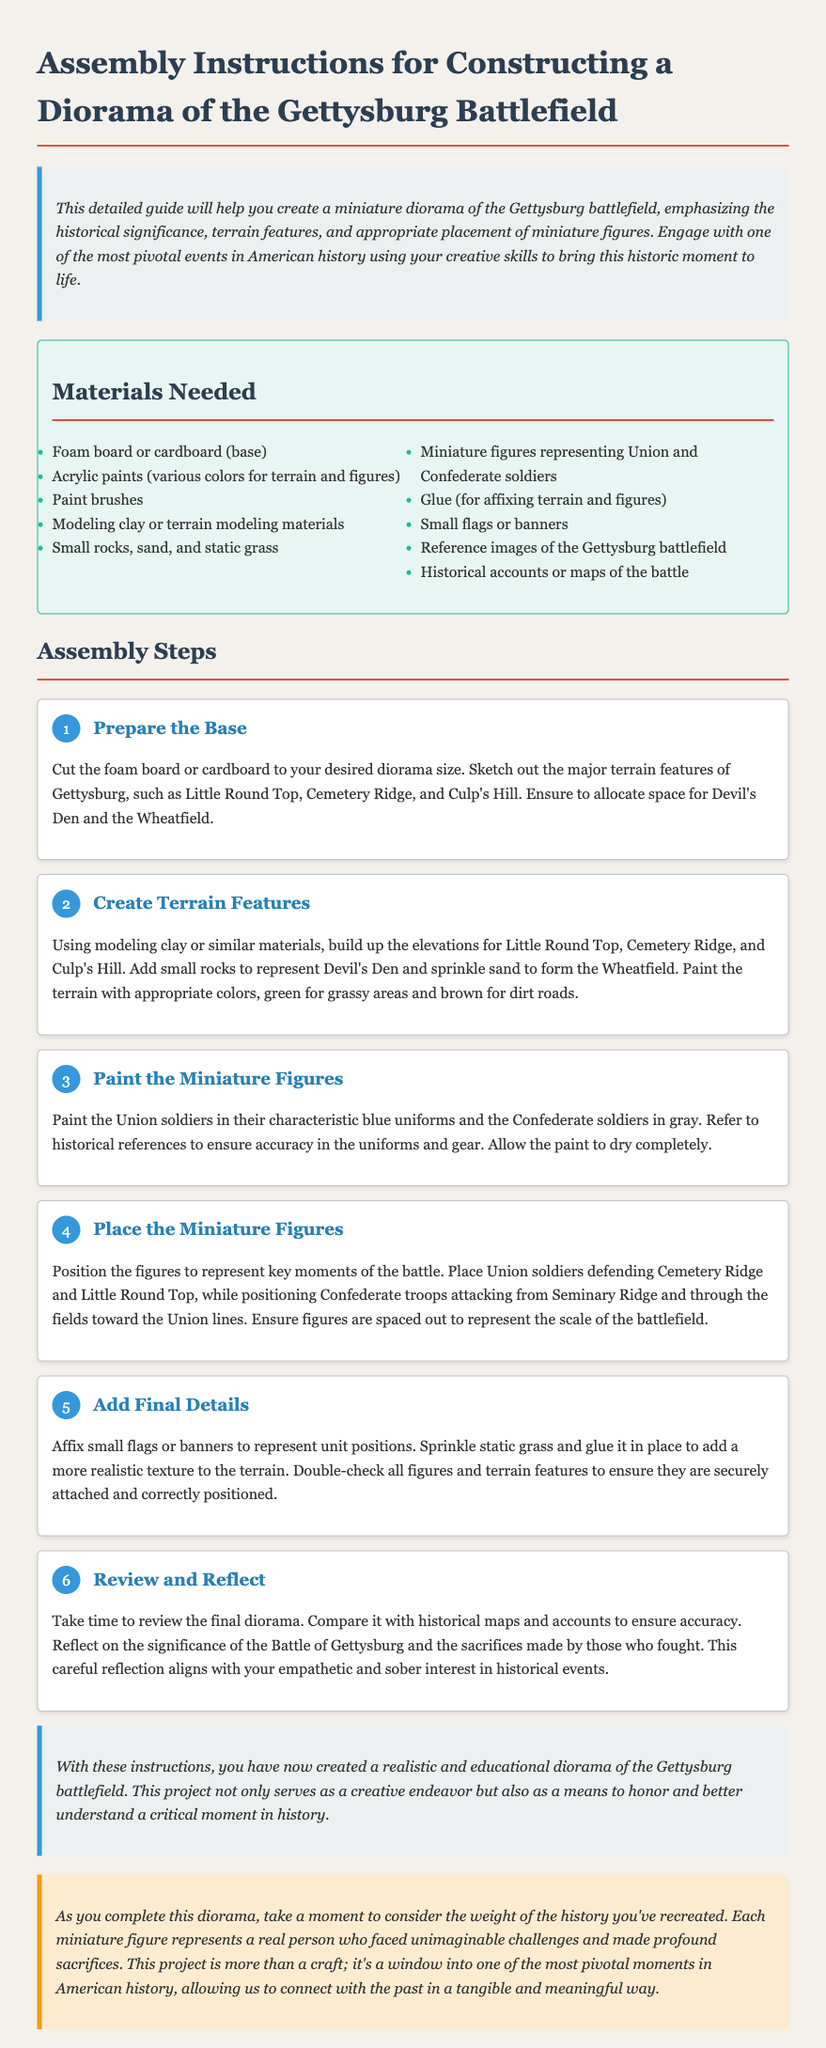What are the materials needed for the diorama? The materials needed are listed in the "Materials Needed" section, including foam board, paints, miniature figures, etc.
Answer: Foam board, acrylic paints, miniature figures, etc How many steps are there in the assembly instructions? The document lists six distinct steps in the "Assembly Steps" section.
Answer: Six What historical features should be represented on the diorama? The instruction step mentions major terrain features such as Little Round Top and Cemetery Ridge which should be included in the diorama.
Answer: Little Round Top, Cemetery Ridge, Culp's Hill What color should the Union soldiers' uniforms be painted? The instructions specifically state that Union soldiers should be painted in their characteristic blue uniforms.
Answer: Blue Why is it important to review the diorama against historical maps? This reflection is based on the need to ensure accuracy in the representation of the battlefield, thus connecting with the events accurately.
Answer: To ensure accuracy What is the purpose of adding small flags or banners? The addition of flags or banners serves to represent unit positions on the battlefield in the diorama.
Answer: Represent unit positions What should you do after completing the diorama? The document suggests that one should take time to reflect on the significance of the Battle of Gettysburg and the sacrifices made.
Answer: Reflect on significance What does the conclusion of the instructions emphasize? The conclusion highlights the dual purpose of the project as a creative endeavor while honoring and understanding history.
Answer: Creative endeavor and historical understanding 